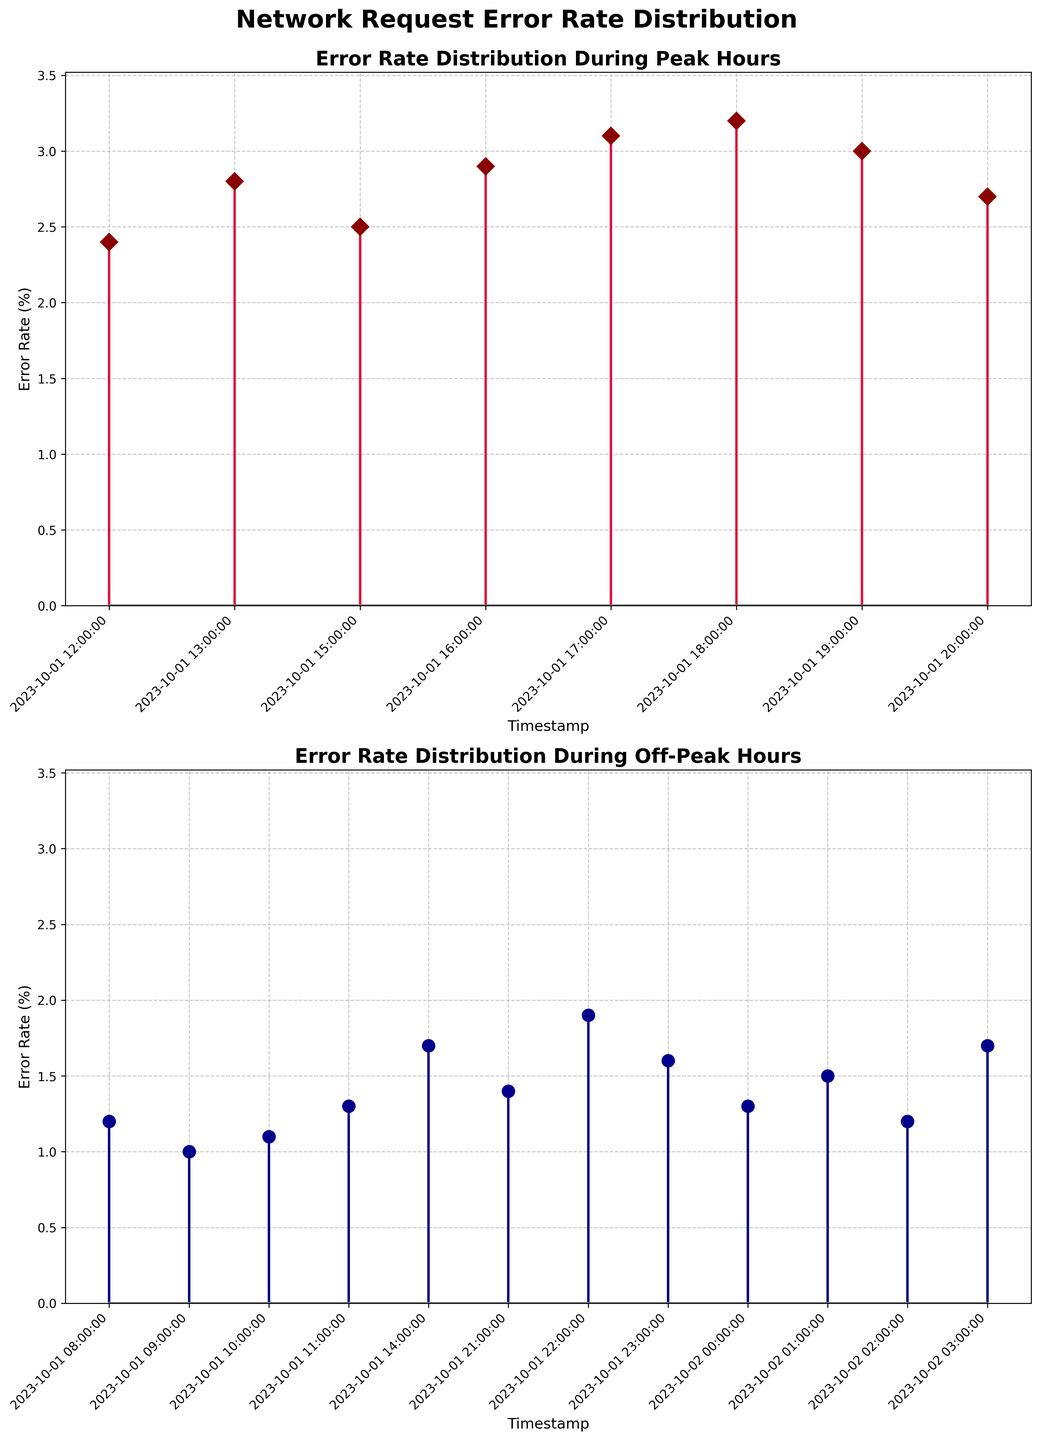How many unique timestamps are plotted in the figure? From the figure, we count the number of unique x-axis points, each representing a distinct timestamp. As the data spans two subplots, we count the timestamps for both peak and off-peak hours together.
Answer: 20 What's the maximum error rate during peak hours? Looking at the "Error Rate Distribution During Peak Hours" subplot, identify the highest y-axis value corresponding to peak hours. The marker at the highest point represents the maximum error rate.
Answer: 3.2 Compare the peak and off-peak hours: which period has higher average error rates? To find this, we need the average of error rates during peak hours and the average during off-peak hours. Summing up all error rates in each respective subplot and dividing by the number of data points gives us the average. The peak hours show generally higher error rates from visual inspection.
Answer: Peak hours Which app exhibited the highest error rate during off-peak hours? In the subplot for off-peak hours, identify the highest error rate visual and check the corresponding app name from the x-axis.
Answer: Twitter How do the error rates of Instagram during peak hours compare to off-peak hours? Compare the stem plots for Instagram in both subplots. During peak hours, the error rates appear higher, specifically at points around 12:00 to 18:00, compared to lower error rates in off-peak hours around 08:00 and 23:00.
Answer: Higher during peak hours What is the range of error rates during off-peak hours? Find the minimum and maximum error rates in the off-peak subplot and calculate the range by subtracting the minimum from the maximum.
Answer: 1.9 During which hour is the peak error rate observed, and which app does it correspond to? In the peak hours subplot, find the timestamp labeled 18:00, which has the highest error rate, and note the corresponding app from the x-axis.
Answer: 18:00, Instagram Are there any timestamps where error rates are equal between peak and off-peak hours? Look for any overlapping y-values in both subplots and cross-check the corresponding timestamps to see if they align exactly.
Answer: No Which subplot has more data points, peak hours or off-peak hours? Count the number of markers (stem points) in each subplot. Compare the counts to determine which subplot has more data points.
Answer: Off-peak hours What is the total number of stemlines used across the figure? Add the count of stemlines in both the peak and off-peak subplots. Each stemline represents a single data point.
Answer: 20 